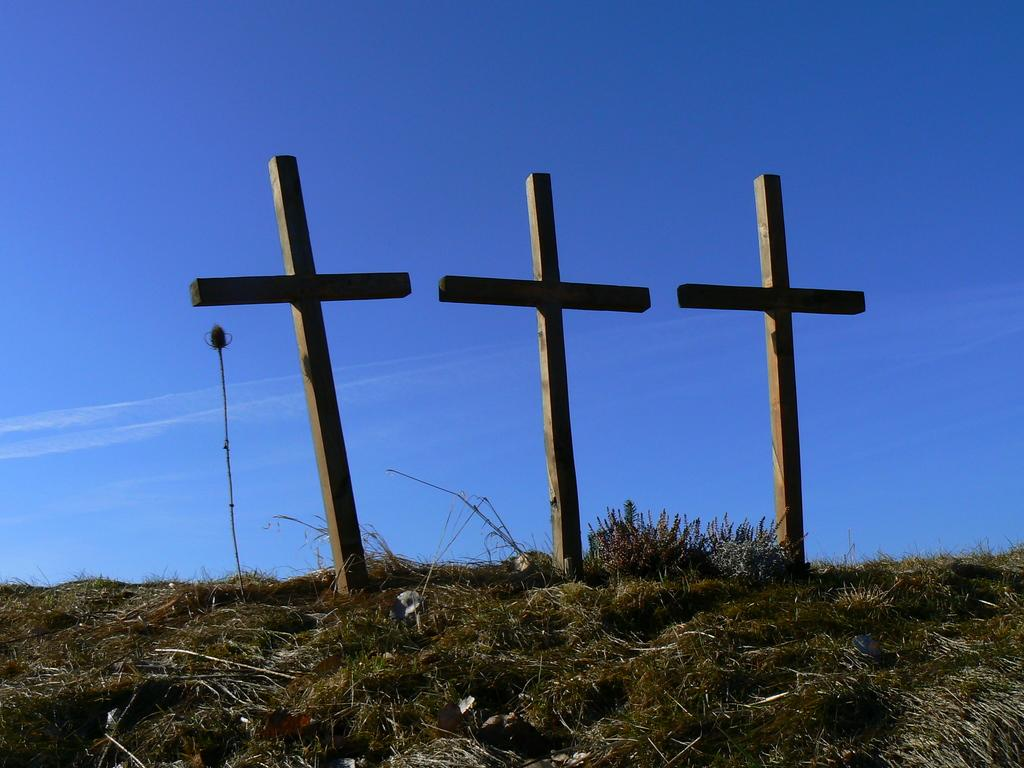What is the main subject of the image? The main subject of the image is three crosses on a hill. What type of vegetation can be seen on the hill? Grass and plants are present on the hill. What is visible in the sky in the background of the image? There are clouds in the sky in the background of the image. How many canvases are hanging on the wall in the image? There are no canvases present in the image; it features a hill with three crosses and a sky with clouds. What type of office furniture can be seen in the image? There is no office furniture present in the image; it features a hill with three crosses and a sky with clouds. 